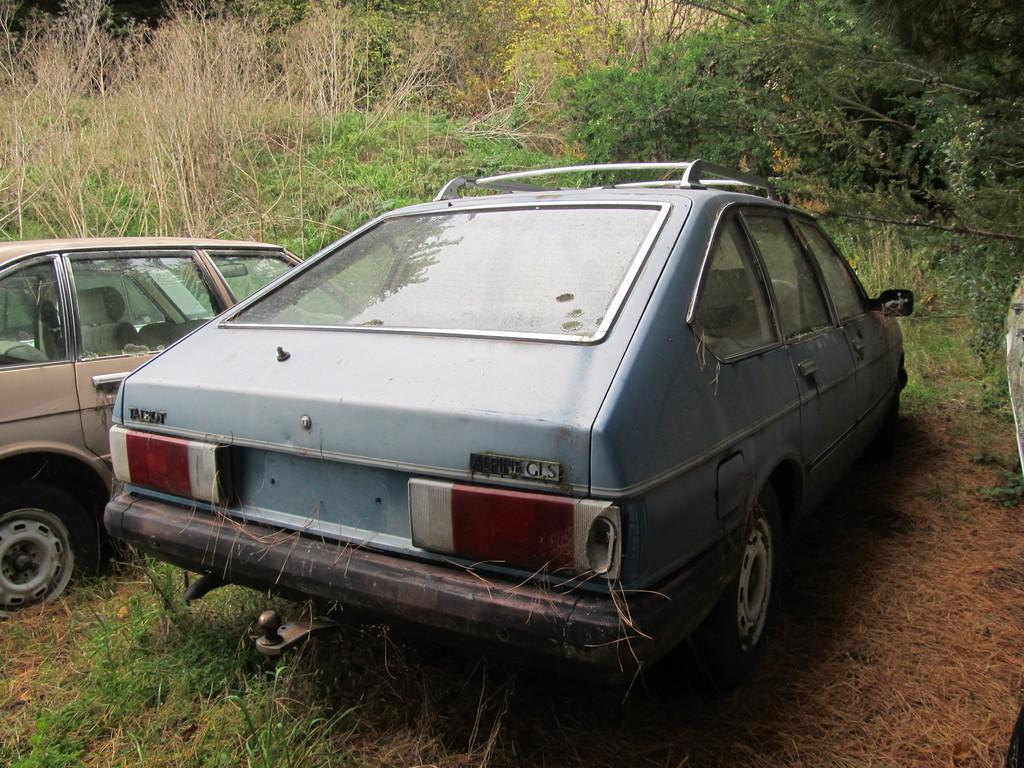How many cars are visible in the image? There are two cars in the image. What type of vegetation can be seen in the image? There are green color plants in the image. What type of gun is being used by the governor in the image? There is no governor or gun present in the image; it only features two cars and green color plants. 